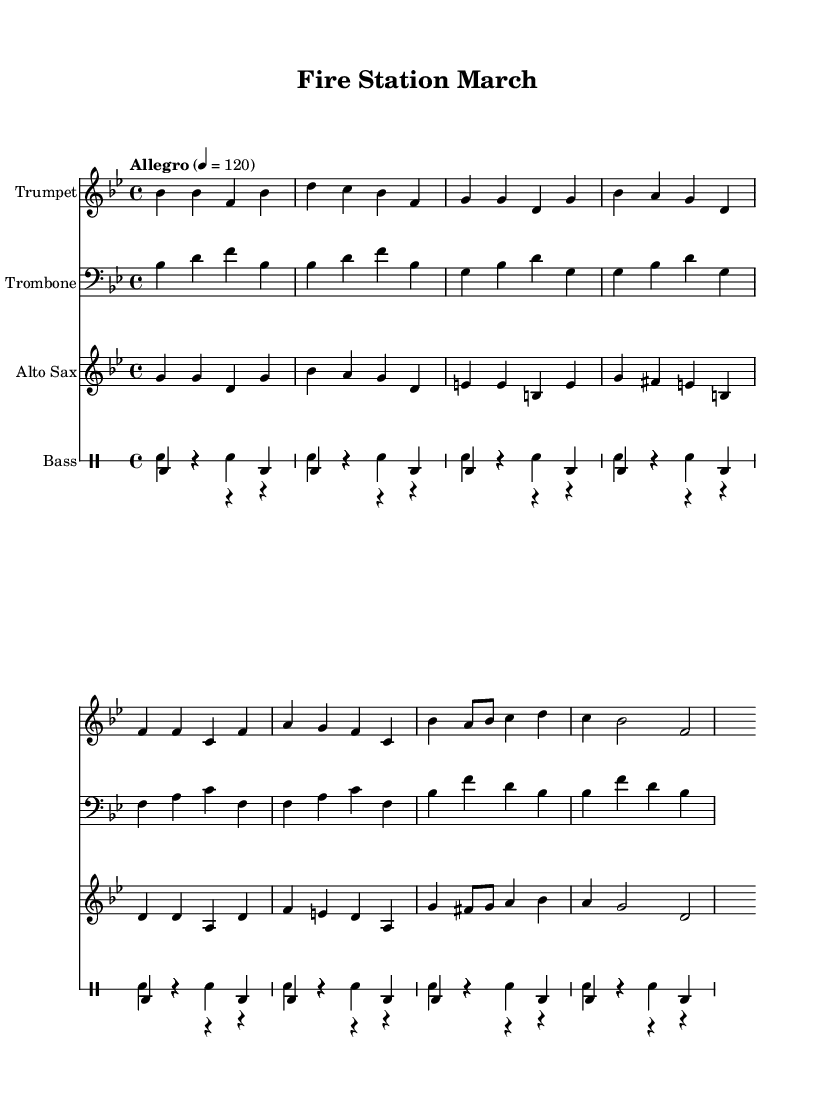What is the key signature of this music? The key signature is B flat major, which has two flats (B flat and E flat) indicated at the beginning of the staff.
Answer: B flat major What is the time signature of this music? The time signature appears at the beginning of the staff as a 4 over 4, indicating that there are four beats in each measure, and each beat is a quarter note.
Answer: 4/4 What is the tempo marking for this piece? The tempo marking is noted above the staff as "Allegro," which indicates a lively and brisk pace.
Answer: Allegro How many instruments are included in this score? The score includes four instrumental parts: trumpet, trombone, alto sax, and a drum section consisting of snare and bass drums.
Answer: Four What is the first note played by the trumpet? The first note played by the trumpet is B flat, as indicated by the note on the staff at the beginning of the trumpet part.
Answer: B flat How many measures are in the trumpet part? By counting the individual measures listed in the trumpet part, there are a total of eight measures throughout the piece.
Answer: Eight 